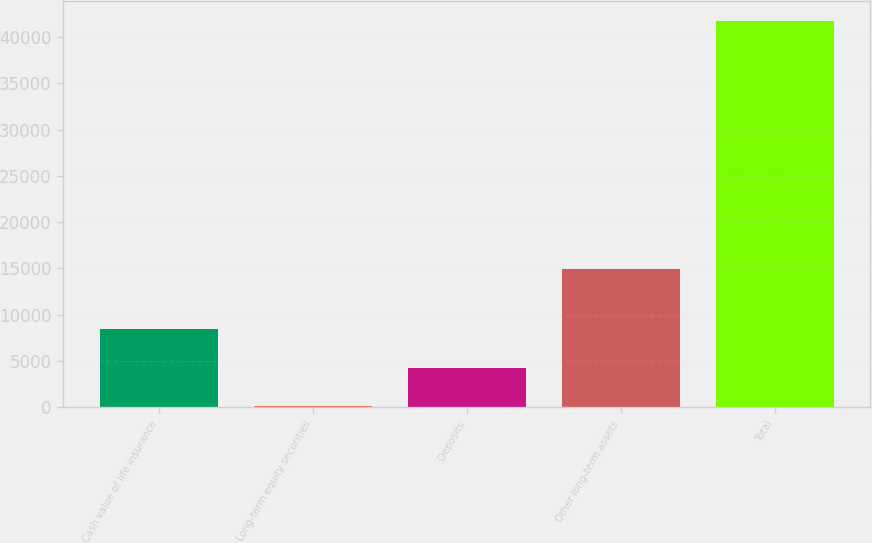Convert chart to OTSL. <chart><loc_0><loc_0><loc_500><loc_500><bar_chart><fcel>Cash value of life insurance<fcel>Long-term equity securities<fcel>Deposits<fcel>Other long-term assets<fcel>Total<nl><fcel>8428.6<fcel>100<fcel>4264.3<fcel>14978<fcel>41743<nl></chart> 